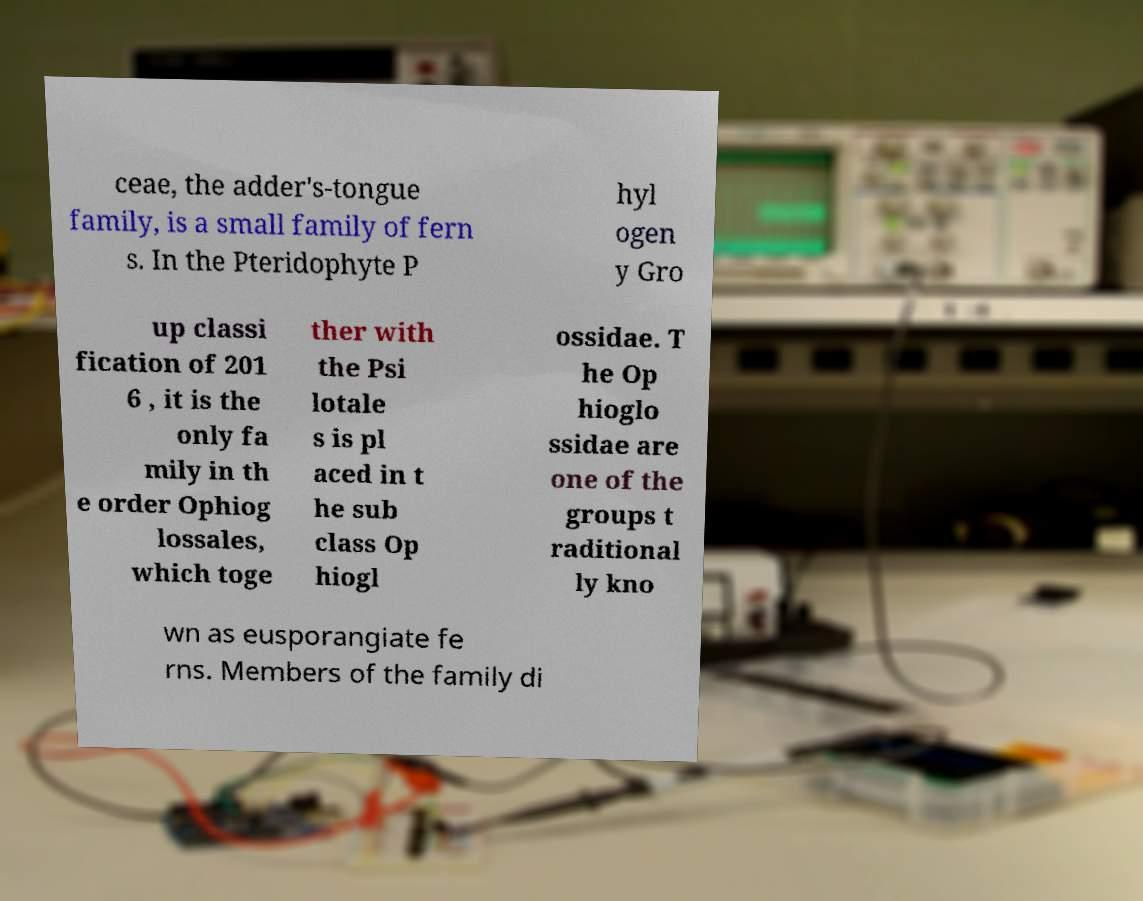Please read and relay the text visible in this image. What does it say? ceae, the adder's-tongue family, is a small family of fern s. In the Pteridophyte P hyl ogen y Gro up classi fication of 201 6 , it is the only fa mily in th e order Ophiog lossales, which toge ther with the Psi lotale s is pl aced in t he sub class Op hiogl ossidae. T he Op hioglo ssidae are one of the groups t raditional ly kno wn as eusporangiate fe rns. Members of the family di 